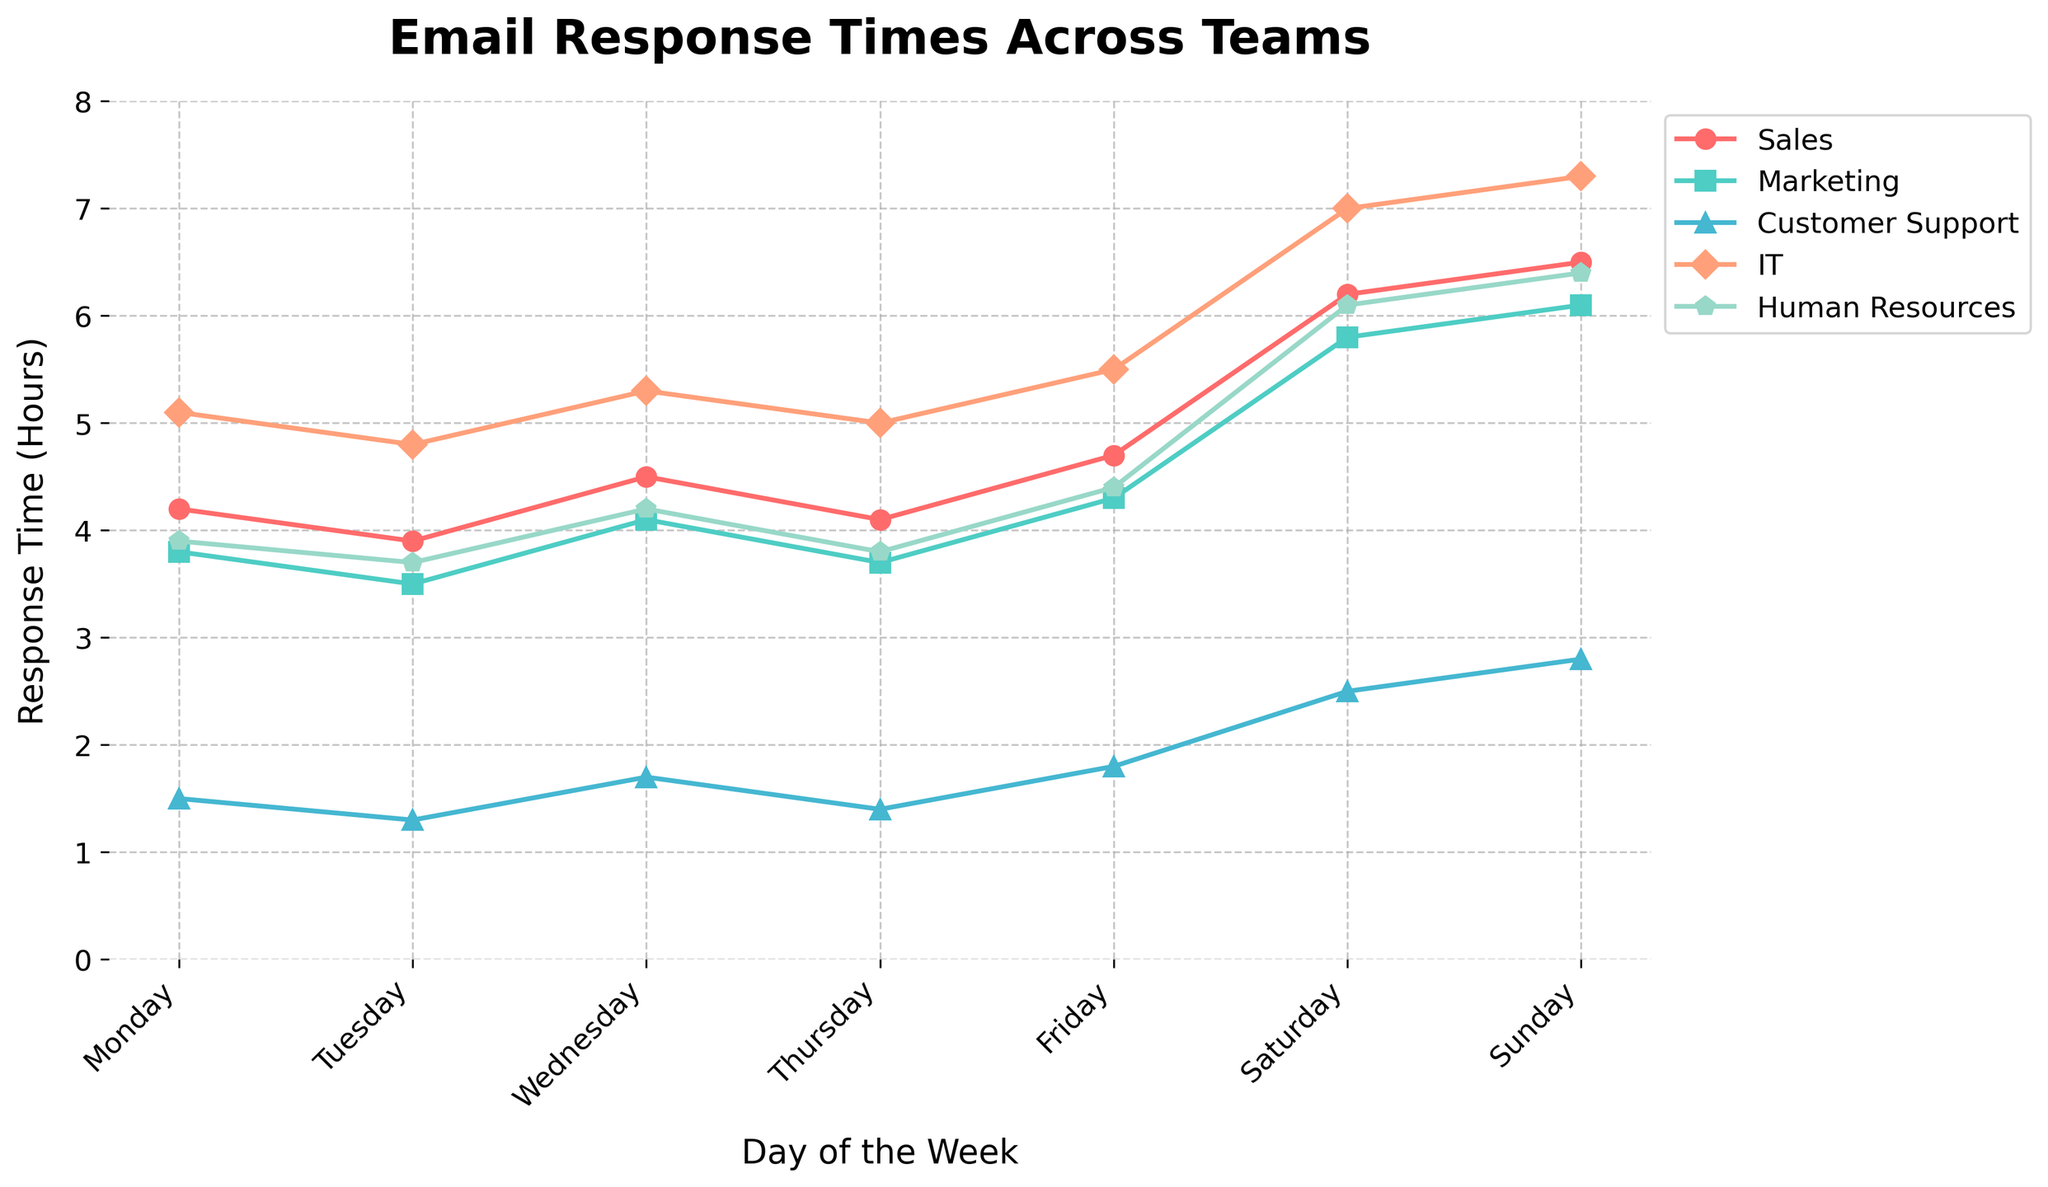What is the average email response time for the Marketing team over the week? To find the average, sum the response times for the Marketing team and divide by the number of days. (3.8 + 3.5 + 4.1 + 3.7 + 4.3 + 5.8 + 6.1) / 7 = 31.3 / 7 ≈ 4.47 hours.
Answer: 4.47 hours On which day does Customer Support have the fastest response time? Check which day has the lowest value for the Customer Support response times. The lowest value is 1.3 on Tuesday.
Answer: Tuesday Which team has the longest email response time on Sunday? Observe the response times across all teams on Sunday. IT has the highest value at 7.3 hours.
Answer: IT How does the average response time of Sales compare to the average response time of IT over the week? Calculate the average response times for both teams and compare. Sales: (4.2 + 3.9 + 4.5 + 4.1 + 4.7 + 6.2 + 6.5) / 7 ≈ 4.73 hours; IT: (5.1 + 4.8 + 5.3 + 5.0 + 5.5 + 7.0 + 7.3) / 7 ≈ 5.71 hours. IT has a higher average response time.
Answer: IT has a higher average What is the total email response time for Human Resources from Monday to Friday? Sum the response times for Human Resources from Monday to Friday. 3.9 + 3.7 + 4.2 + 3.8 + 4.4 = 20.0 hours.
Answer: 20.0 hours By how much does the response time of Sales change from Monday to Friday? Subtract the response time on Monday from the response time on Friday for the Sales team. 4.7 - 4.2 = 0.5 hours.
Answer: 0.5 hours How does Customer Support's response time trend over the week? Observe the values for Customer Support throughout the week. The response time gradually increases each day from Monday (1.5) to Sunday (2.8).
Answer: Increases What is the difference between the IT and Customer Support response times on Wednesday? Subtract the response time of Customer Support from the response time of IT on Wednesday. 5.3 - 1.7 = 3.6 hours.
Answer: 3.6 hours On which days does Marketing have a higher response time than Sales? Compare Sales and Marketing response times for each day. Marketing has higher values than Sales on Saturday (5.8 vs. 6.2) and Sunday (6.1 vs. 6.5).
Answer: Saturday, Sunday 